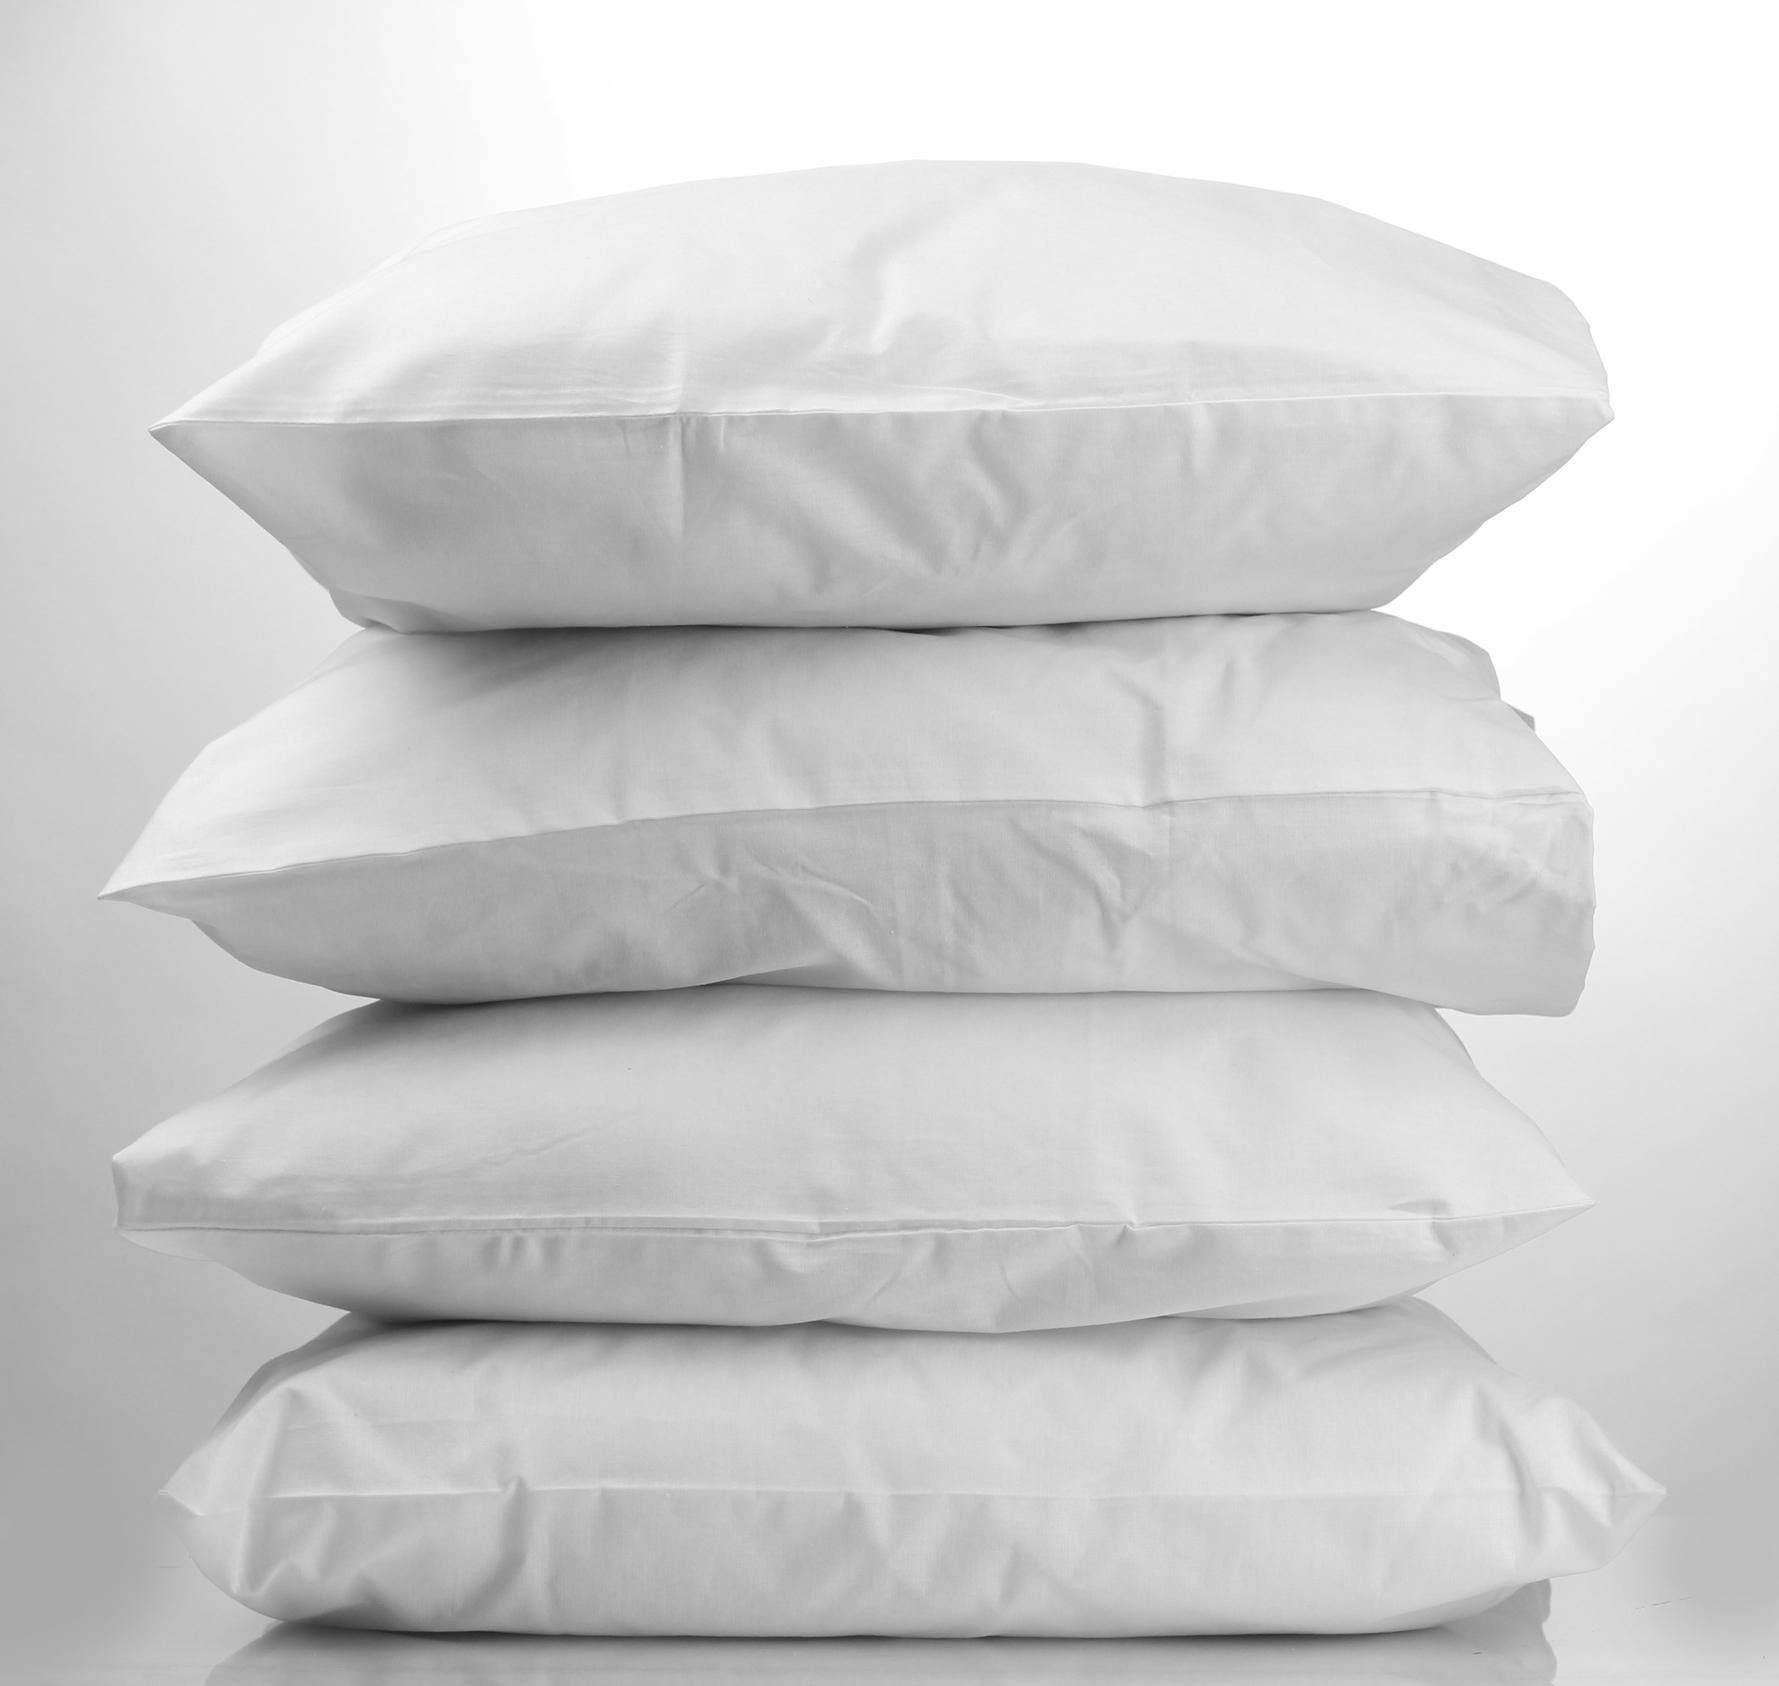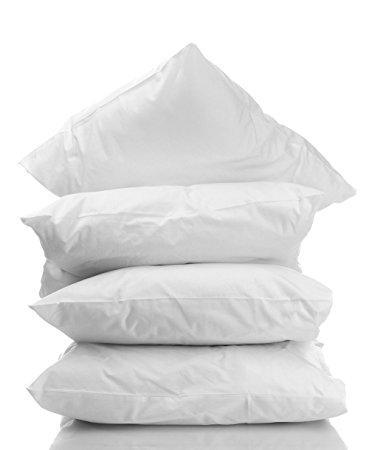The first image is the image on the left, the second image is the image on the right. For the images shown, is this caption "There are two stacks of four pillows." true? Answer yes or no. Yes. The first image is the image on the left, the second image is the image on the right. Analyze the images presented: Is the assertion "The left image contains a vertical stack of exactly four pillows." valid? Answer yes or no. Yes. 